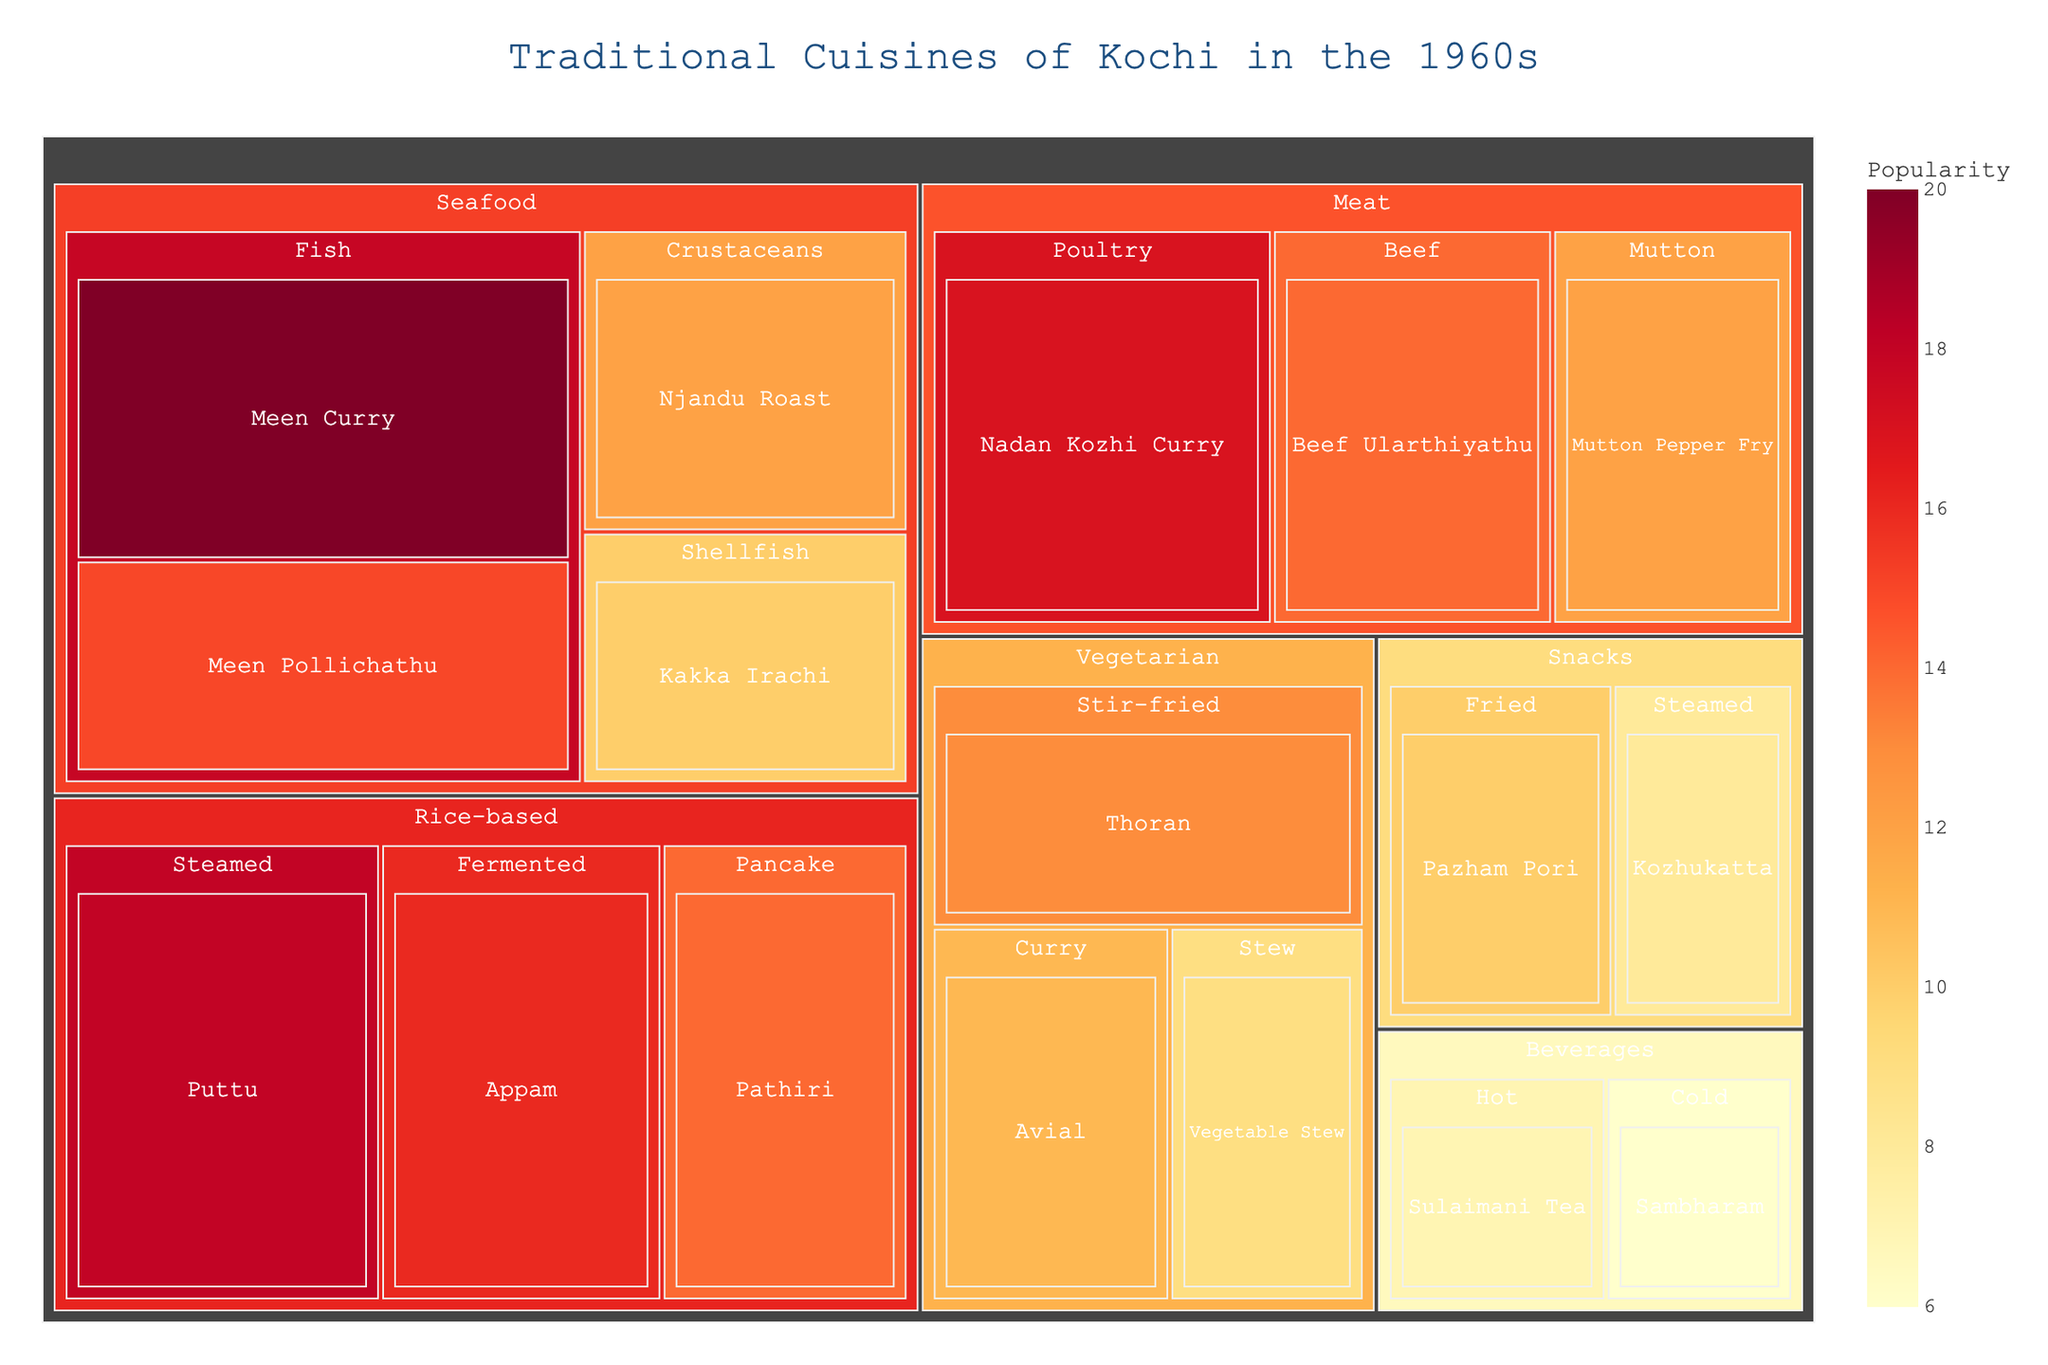What is the title of the treemap? The title of the treemap is usually displayed at the top of the figure. In this case, look for a text that summarizes the content of the visualization.
Answer: Traditional Cuisines of Kochi in the 1960s Which dish has the highest popularity value? To find the dish with the highest popularity value, look for the largest rectangle and/or the darkest color in the treemap, as these visually represent higher values.
Answer: Meen Curry How many dishes are categorized under Vegetarian? To determine the number of dishes in the Vegetarian category, count the subdivisions within the Vegetarian section of the treemap.
Answer: 3 What is the sum of the popularity values for all Rice-based dishes? Add up the popularity values for each dish under the Rice-based category. The dishes are Puttu (18), Appam (16), and Pathiri (14). So, the sum is 18 + 16 + 14.
Answer: 48 How does the popularity of Nadan Kozhi Curry compare to Mutton Pepper Fry? Compare the popularity values given for Nadan Kozhi Curry (17) and Mutton Pepper Fry (12) directly.
Answer: Nadan Kozhi Curry is more popular than Mutton Pepper Fry Which category has the most diverse subcategories? Check each main category and count the number of subcategories they have.
Answer: Seafood Identify any dish related to beverages and its popularity. Look for the Beverages section within the treemap and list one of the dishes and its associated popularity value. There are two options: Sulaimani Tea (7) or Sambharam (6).
Answer: Sulaimani Tea with a popularity of 7 Calculate the average popularity value of all Meat dishes. Add the popularity values of all Meat dishes and then divide by the number of dishes in this category. The dishes and their values are Nadan Kozhi Curry (17), Beef Ularthiyathu (14), and Mutton Pepper Fry (12). The sum is 17 + 14 + 12 = 43. There are 3 dishes, so the average is 43/3.
Answer: 14.33 (approximately 14 when rounded down) What is the least popular snack? Locate the Snacks category and identify the dish with the smallest popularity value.
Answer: Kozhukatta Which has a greater value, Puttu or Appam? Compare the given popularity values for Puttu (18) and Appam (16).
Answer: Puttu 